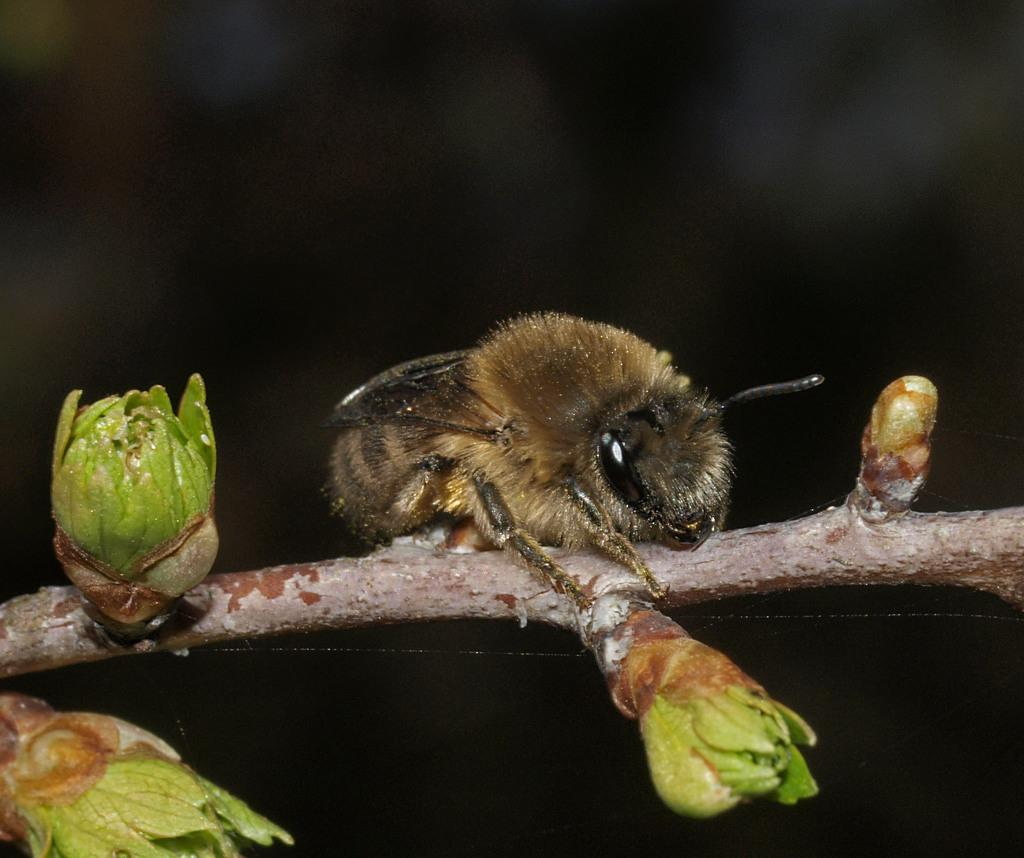What insect can be seen in the image? There is a bee on the stem in the image. What stage of growth are the plants in the image? There are some buds in the image, which suggests they are in the early stages of growth. What is the color of the background in the image? The background of the image is dark. What type of crime is being committed in the image? There is no crime being committed in the image; it features a bee on a stem and some buds. What plant is responsible for the hot temperature in the image? There is no indication of a hot temperature in the image, and no specific plant is mentioned. 